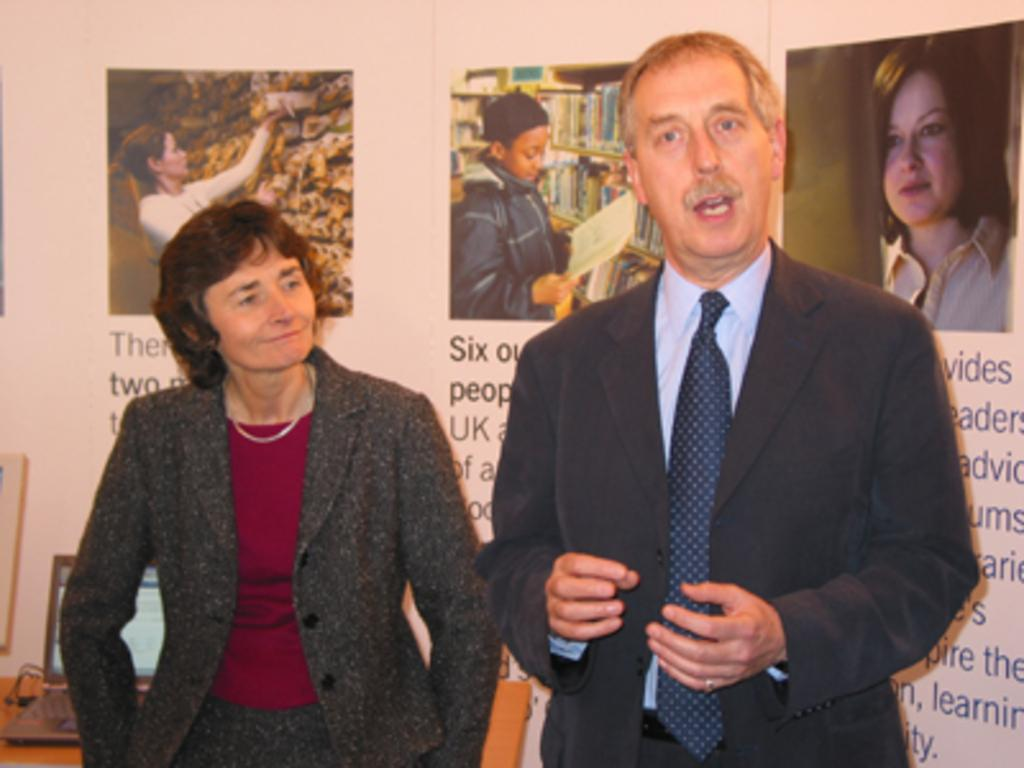How many people are present in the image? There are two people in the image. What are the people wearing? The people are wearing different color dresses. What can be seen on the table in the image? There is a laptop on a table in the image. What is visible in the background of the image? There are posts and a board attached to a wall in the background of the image. What type of cloth is being used to cover the laptop in the image? There is no cloth covering the laptop in the image; it is visible on the table. How many legs does the laptop have in the image? The laptop does not have legs; it is resting on the table. 